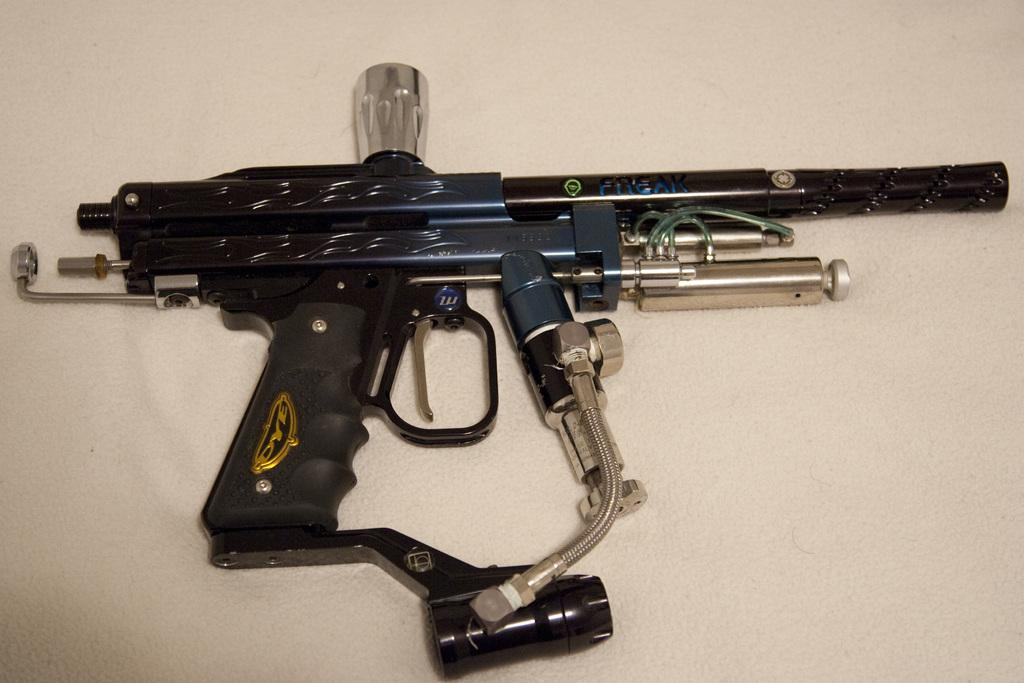What object is present in the image? The gun is in the image. What colors can be seen on the gun? The gun is in blue, black, and silver colors. What role does the actor play in the image? There is no actor present in the image; it features a gun with specific colors. What type of rhythm can be heard in the image? There is no sound or rhythm present in the image; it is a static visual representation of a gun. 